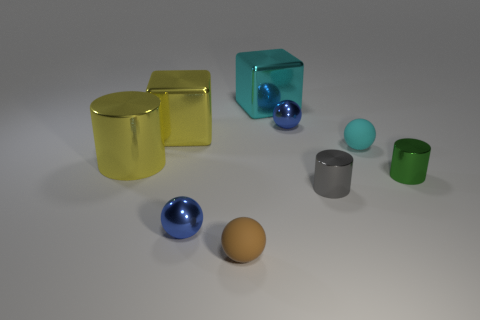Subtract all green blocks. Subtract all purple balls. How many blocks are left? 2 Add 1 small brown matte spheres. How many objects exist? 10 Subtract all blocks. How many objects are left? 7 Add 3 small brown matte balls. How many small brown matte balls exist? 4 Subtract 0 green blocks. How many objects are left? 9 Subtract all small gray metallic cylinders. Subtract all purple matte spheres. How many objects are left? 8 Add 7 large metal cubes. How many large metal cubes are left? 9 